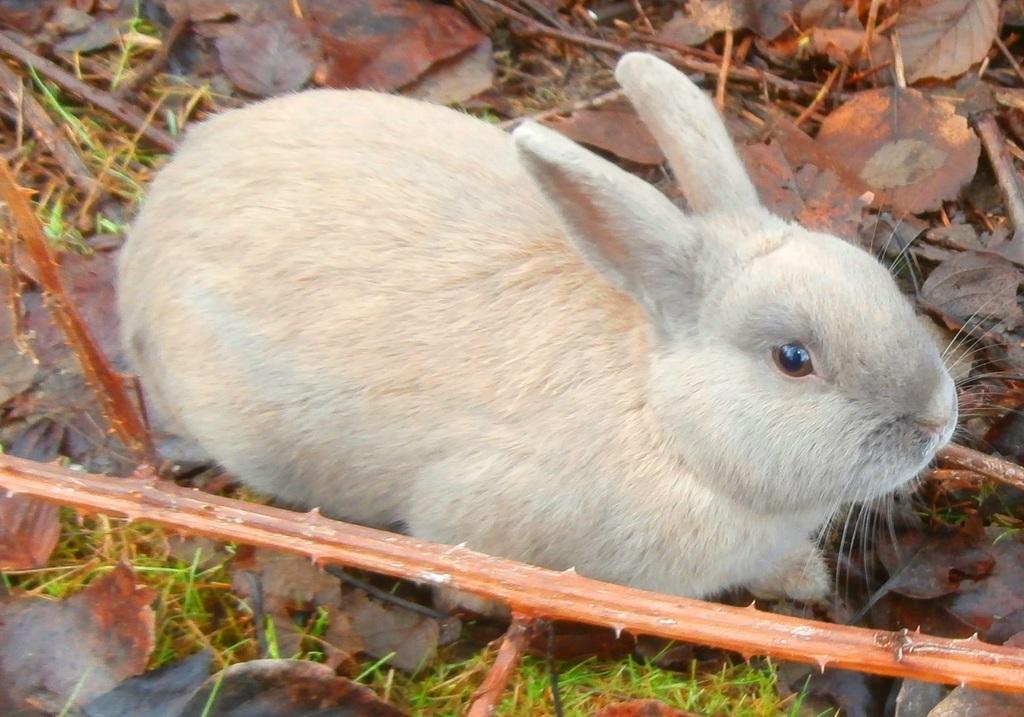Could you give a brief overview of what you see in this image? In the picture we can see a rabbit which is cream in color sitting on the surface, on the surface, we can see some grass, dried twigs and dried leaves. 